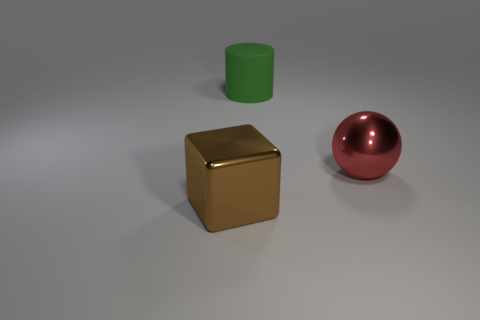Add 1 big green cylinders. How many objects exist? 4 Subtract 0 red cylinders. How many objects are left? 3 Subtract all cubes. How many objects are left? 2 Subtract all blue cubes. Subtract all green balls. How many cubes are left? 1 Subtract all large purple blocks. Subtract all big green objects. How many objects are left? 2 Add 1 metallic objects. How many metallic objects are left? 3 Add 1 big cyan matte spheres. How many big cyan matte spheres exist? 1 